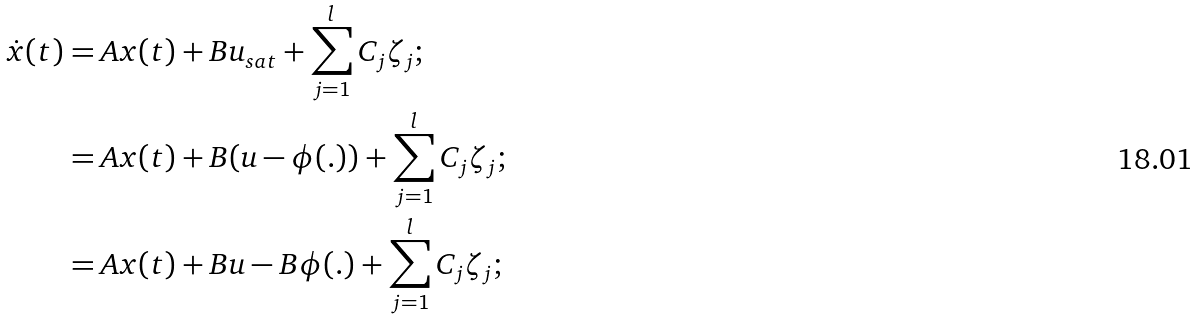<formula> <loc_0><loc_0><loc_500><loc_500>\dot { x } ( t ) & = A x ( t ) + B u _ { s a t } + \sum ^ { l } _ { j = 1 } C _ { j } \zeta _ { j } ; \\ & = A x ( t ) + B ( u - \phi ( . ) ) + \sum ^ { l } _ { j = 1 } C _ { j } \zeta _ { j } ; \\ & = A x ( t ) + B u - B \phi ( . ) + \sum ^ { l } _ { j = 1 } C _ { j } \zeta _ { j } ; \\</formula> 